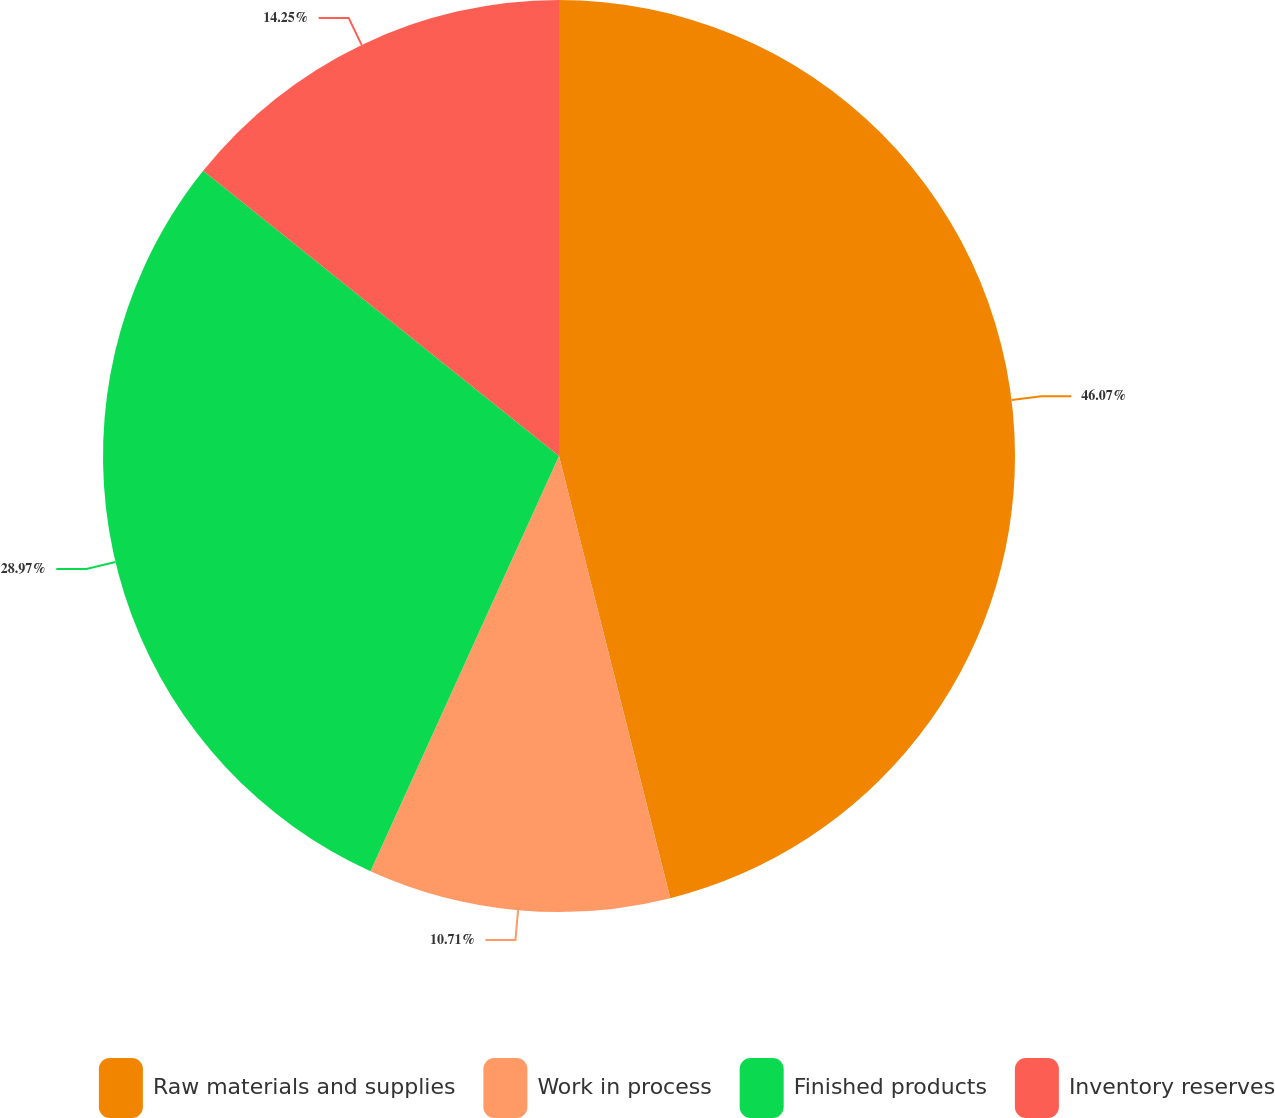Convert chart to OTSL. <chart><loc_0><loc_0><loc_500><loc_500><pie_chart><fcel>Raw materials and supplies<fcel>Work in process<fcel>Finished products<fcel>Inventory reserves<nl><fcel>46.08%<fcel>10.71%<fcel>28.97%<fcel>14.25%<nl></chart> 